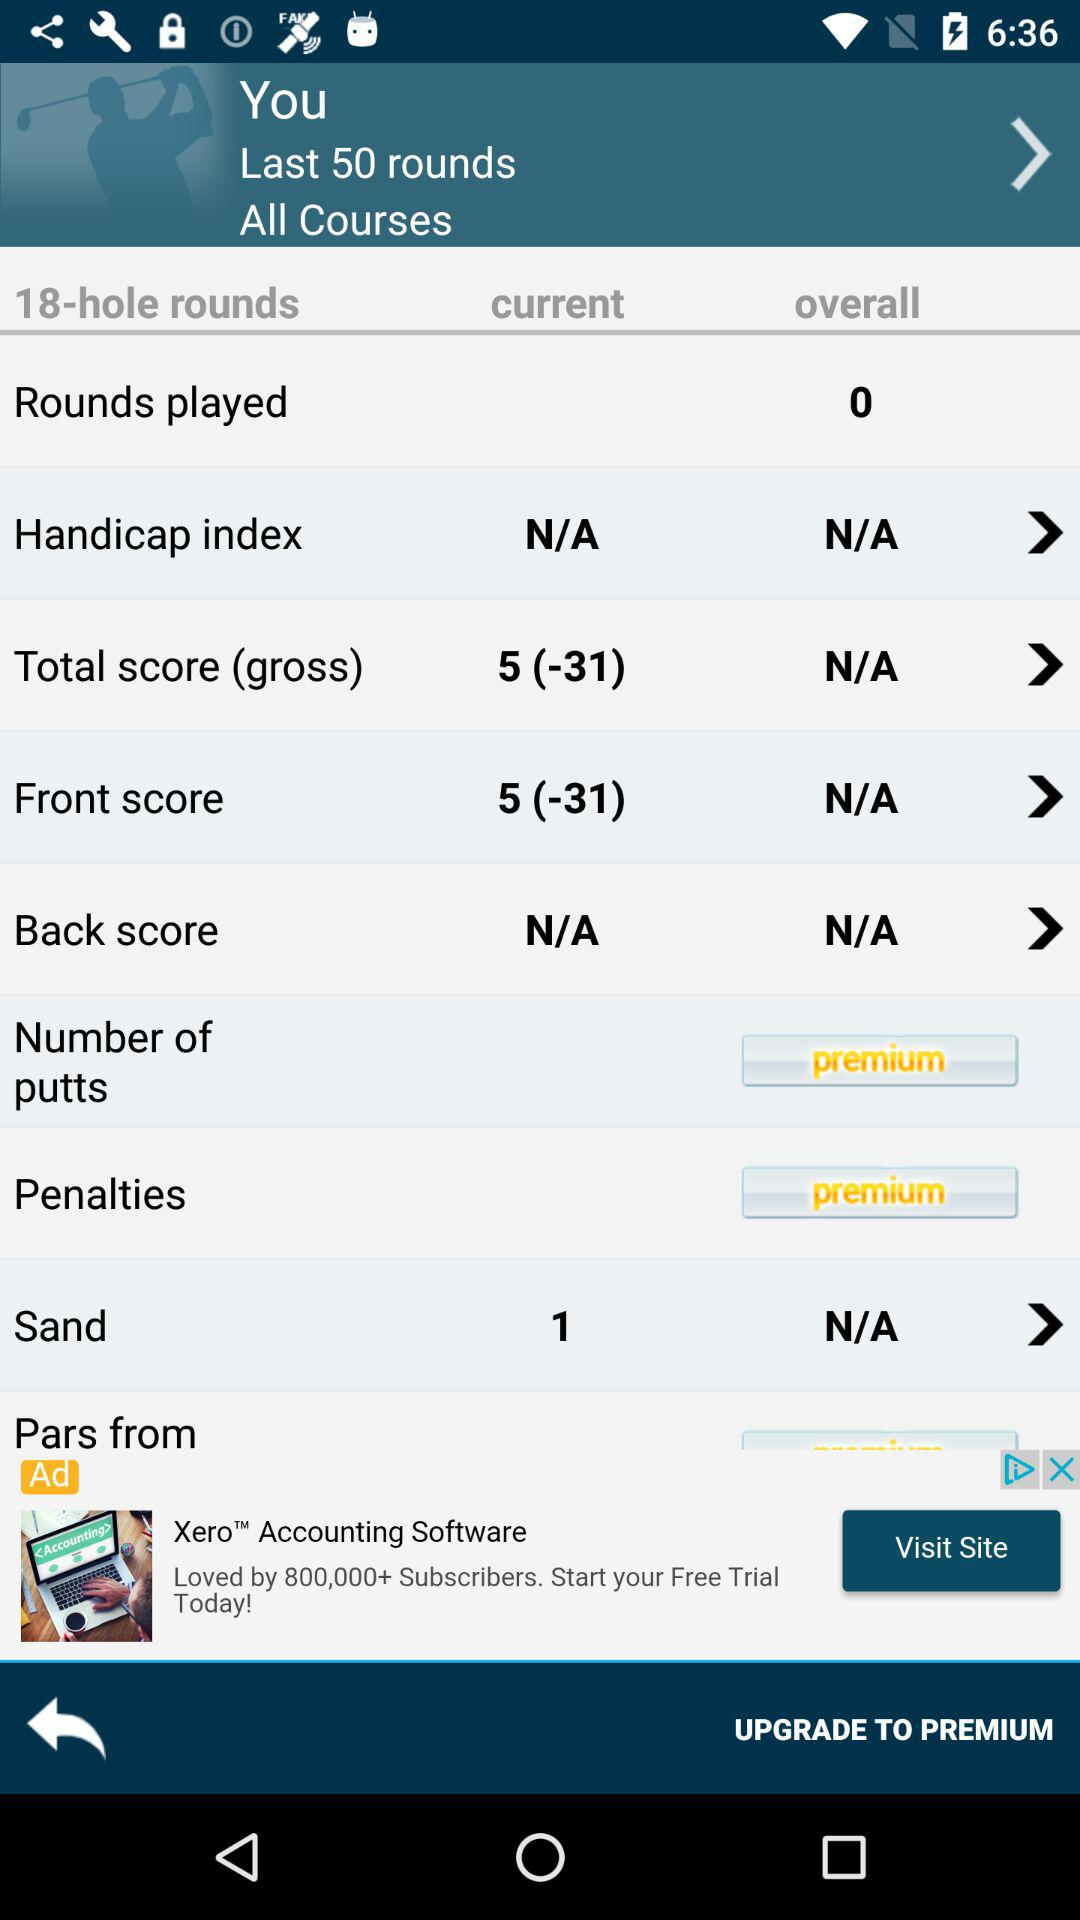What is the current total score? The current total score is 5 (-31). 